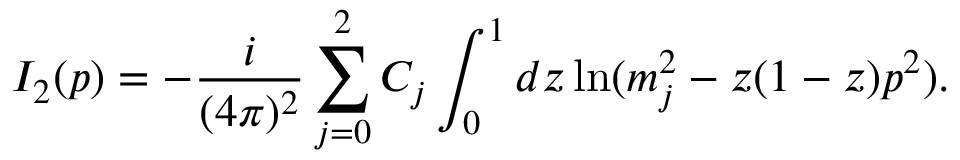<formula> <loc_0><loc_0><loc_500><loc_500>I _ { 2 } ( p ) = - \frac { i } ( 4 \pi ) ^ { 2 } } \sum _ { j = 0 } ^ { 2 } C _ { j } \int _ { 0 } ^ { 1 } d z \ln ( m _ { j } ^ { 2 } - z ( 1 - z ) p ^ { 2 } ) .</formula> 